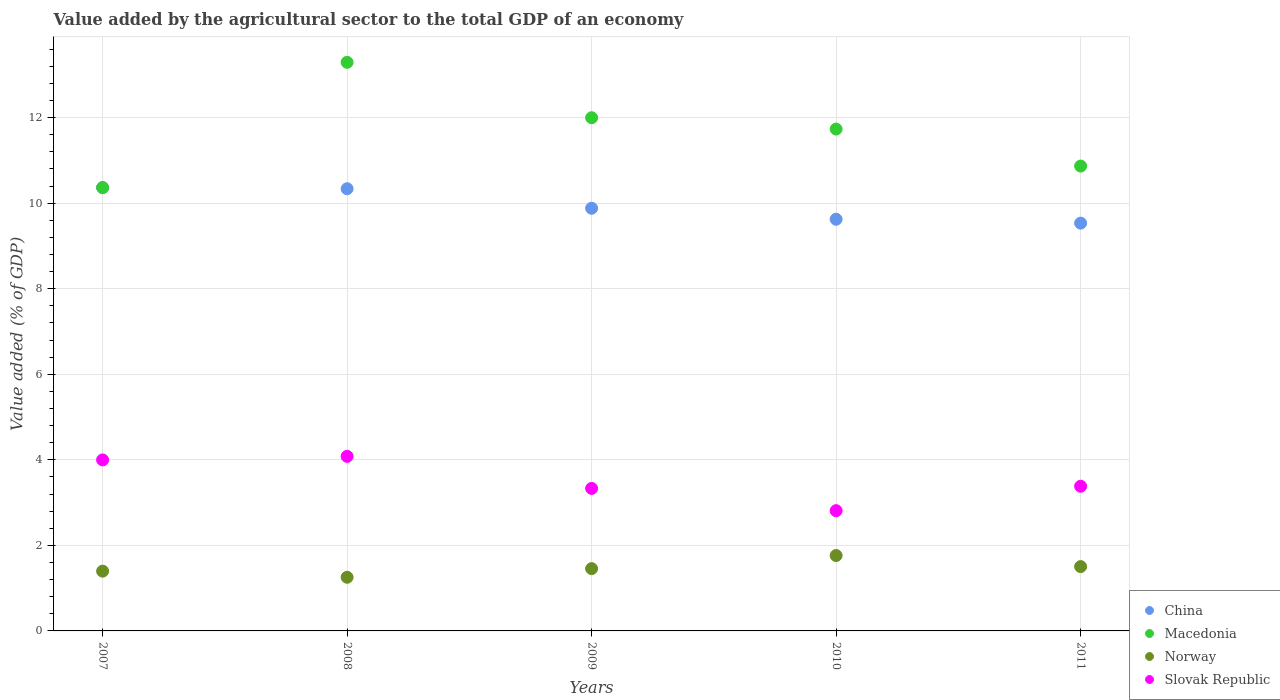How many different coloured dotlines are there?
Your answer should be compact. 4. Is the number of dotlines equal to the number of legend labels?
Provide a succinct answer. Yes. What is the value added by the agricultural sector to the total GDP in Macedonia in 2008?
Provide a short and direct response. 13.29. Across all years, what is the maximum value added by the agricultural sector to the total GDP in Slovak Republic?
Offer a terse response. 4.08. Across all years, what is the minimum value added by the agricultural sector to the total GDP in Slovak Republic?
Provide a short and direct response. 2.81. In which year was the value added by the agricultural sector to the total GDP in Norway maximum?
Provide a succinct answer. 2010. In which year was the value added by the agricultural sector to the total GDP in Slovak Republic minimum?
Your response must be concise. 2010. What is the total value added by the agricultural sector to the total GDP in Slovak Republic in the graph?
Ensure brevity in your answer.  17.61. What is the difference between the value added by the agricultural sector to the total GDP in Macedonia in 2009 and that in 2011?
Provide a succinct answer. 1.13. What is the difference between the value added by the agricultural sector to the total GDP in Macedonia in 2011 and the value added by the agricultural sector to the total GDP in Slovak Republic in 2010?
Keep it short and to the point. 8.06. What is the average value added by the agricultural sector to the total GDP in Slovak Republic per year?
Provide a succinct answer. 3.52. In the year 2009, what is the difference between the value added by the agricultural sector to the total GDP in China and value added by the agricultural sector to the total GDP in Norway?
Your answer should be compact. 8.43. In how many years, is the value added by the agricultural sector to the total GDP in Norway greater than 1.2000000000000002 %?
Make the answer very short. 5. What is the ratio of the value added by the agricultural sector to the total GDP in Norway in 2007 to that in 2011?
Your answer should be compact. 0.93. Is the difference between the value added by the agricultural sector to the total GDP in China in 2009 and 2011 greater than the difference between the value added by the agricultural sector to the total GDP in Norway in 2009 and 2011?
Offer a very short reply. Yes. What is the difference between the highest and the second highest value added by the agricultural sector to the total GDP in Macedonia?
Provide a short and direct response. 1.3. What is the difference between the highest and the lowest value added by the agricultural sector to the total GDP in China?
Offer a very short reply. 0.83. In how many years, is the value added by the agricultural sector to the total GDP in China greater than the average value added by the agricultural sector to the total GDP in China taken over all years?
Make the answer very short. 2. Does the value added by the agricultural sector to the total GDP in Slovak Republic monotonically increase over the years?
Offer a terse response. No. Is the value added by the agricultural sector to the total GDP in China strictly less than the value added by the agricultural sector to the total GDP in Macedonia over the years?
Your answer should be compact. No. Are the values on the major ticks of Y-axis written in scientific E-notation?
Your answer should be very brief. No. Does the graph contain any zero values?
Keep it short and to the point. No. Does the graph contain grids?
Your answer should be compact. Yes. Where does the legend appear in the graph?
Your answer should be very brief. Bottom right. What is the title of the graph?
Ensure brevity in your answer.  Value added by the agricultural sector to the total GDP of an economy. Does "Northern Mariana Islands" appear as one of the legend labels in the graph?
Make the answer very short. No. What is the label or title of the X-axis?
Your answer should be compact. Years. What is the label or title of the Y-axis?
Offer a very short reply. Value added (% of GDP). What is the Value added (% of GDP) in China in 2007?
Your answer should be very brief. 10.37. What is the Value added (% of GDP) of Macedonia in 2007?
Provide a short and direct response. 10.36. What is the Value added (% of GDP) of Norway in 2007?
Give a very brief answer. 1.4. What is the Value added (% of GDP) in Slovak Republic in 2007?
Offer a terse response. 4. What is the Value added (% of GDP) in China in 2008?
Give a very brief answer. 10.34. What is the Value added (% of GDP) in Macedonia in 2008?
Your response must be concise. 13.29. What is the Value added (% of GDP) in Norway in 2008?
Keep it short and to the point. 1.25. What is the Value added (% of GDP) of Slovak Republic in 2008?
Ensure brevity in your answer.  4.08. What is the Value added (% of GDP) in China in 2009?
Offer a very short reply. 9.88. What is the Value added (% of GDP) in Macedonia in 2009?
Your answer should be compact. 12. What is the Value added (% of GDP) in Norway in 2009?
Provide a succinct answer. 1.46. What is the Value added (% of GDP) of Slovak Republic in 2009?
Offer a very short reply. 3.33. What is the Value added (% of GDP) in China in 2010?
Provide a short and direct response. 9.62. What is the Value added (% of GDP) of Macedonia in 2010?
Your answer should be compact. 11.73. What is the Value added (% of GDP) of Norway in 2010?
Your answer should be very brief. 1.76. What is the Value added (% of GDP) in Slovak Republic in 2010?
Keep it short and to the point. 2.81. What is the Value added (% of GDP) in China in 2011?
Keep it short and to the point. 9.53. What is the Value added (% of GDP) in Macedonia in 2011?
Give a very brief answer. 10.87. What is the Value added (% of GDP) of Norway in 2011?
Provide a succinct answer. 1.5. What is the Value added (% of GDP) of Slovak Republic in 2011?
Give a very brief answer. 3.38. Across all years, what is the maximum Value added (% of GDP) in China?
Offer a very short reply. 10.37. Across all years, what is the maximum Value added (% of GDP) in Macedonia?
Offer a very short reply. 13.29. Across all years, what is the maximum Value added (% of GDP) in Norway?
Offer a terse response. 1.76. Across all years, what is the maximum Value added (% of GDP) of Slovak Republic?
Make the answer very short. 4.08. Across all years, what is the minimum Value added (% of GDP) in China?
Your answer should be very brief. 9.53. Across all years, what is the minimum Value added (% of GDP) in Macedonia?
Your answer should be very brief. 10.36. Across all years, what is the minimum Value added (% of GDP) of Norway?
Ensure brevity in your answer.  1.25. Across all years, what is the minimum Value added (% of GDP) of Slovak Republic?
Your response must be concise. 2.81. What is the total Value added (% of GDP) of China in the graph?
Your answer should be compact. 49.74. What is the total Value added (% of GDP) of Macedonia in the graph?
Offer a terse response. 58.26. What is the total Value added (% of GDP) of Norway in the graph?
Your answer should be very brief. 7.37. What is the total Value added (% of GDP) in Slovak Republic in the graph?
Your answer should be compact. 17.61. What is the difference between the Value added (% of GDP) of China in 2007 and that in 2008?
Give a very brief answer. 0.03. What is the difference between the Value added (% of GDP) in Macedonia in 2007 and that in 2008?
Offer a terse response. -2.93. What is the difference between the Value added (% of GDP) of Norway in 2007 and that in 2008?
Make the answer very short. 0.14. What is the difference between the Value added (% of GDP) of Slovak Republic in 2007 and that in 2008?
Your answer should be compact. -0.08. What is the difference between the Value added (% of GDP) in China in 2007 and that in 2009?
Your response must be concise. 0.48. What is the difference between the Value added (% of GDP) of Macedonia in 2007 and that in 2009?
Keep it short and to the point. -1.63. What is the difference between the Value added (% of GDP) in Norway in 2007 and that in 2009?
Give a very brief answer. -0.06. What is the difference between the Value added (% of GDP) in China in 2007 and that in 2010?
Give a very brief answer. 0.74. What is the difference between the Value added (% of GDP) in Macedonia in 2007 and that in 2010?
Make the answer very short. -1.37. What is the difference between the Value added (% of GDP) of Norway in 2007 and that in 2010?
Keep it short and to the point. -0.36. What is the difference between the Value added (% of GDP) of Slovak Republic in 2007 and that in 2010?
Your answer should be compact. 1.19. What is the difference between the Value added (% of GDP) in China in 2007 and that in 2011?
Your answer should be very brief. 0.83. What is the difference between the Value added (% of GDP) of Macedonia in 2007 and that in 2011?
Offer a terse response. -0.5. What is the difference between the Value added (% of GDP) in Norway in 2007 and that in 2011?
Your response must be concise. -0.11. What is the difference between the Value added (% of GDP) in Slovak Republic in 2007 and that in 2011?
Offer a very short reply. 0.62. What is the difference between the Value added (% of GDP) of China in 2008 and that in 2009?
Ensure brevity in your answer.  0.46. What is the difference between the Value added (% of GDP) in Macedonia in 2008 and that in 2009?
Offer a very short reply. 1.3. What is the difference between the Value added (% of GDP) in Norway in 2008 and that in 2009?
Your response must be concise. -0.2. What is the difference between the Value added (% of GDP) of Slovak Republic in 2008 and that in 2009?
Your answer should be compact. 0.75. What is the difference between the Value added (% of GDP) in China in 2008 and that in 2010?
Make the answer very short. 0.71. What is the difference between the Value added (% of GDP) of Macedonia in 2008 and that in 2010?
Offer a terse response. 1.56. What is the difference between the Value added (% of GDP) of Norway in 2008 and that in 2010?
Your answer should be compact. -0.51. What is the difference between the Value added (% of GDP) of Slovak Republic in 2008 and that in 2010?
Give a very brief answer. 1.27. What is the difference between the Value added (% of GDP) in China in 2008 and that in 2011?
Provide a short and direct response. 0.81. What is the difference between the Value added (% of GDP) in Macedonia in 2008 and that in 2011?
Your answer should be very brief. 2.43. What is the difference between the Value added (% of GDP) of Norway in 2008 and that in 2011?
Your response must be concise. -0.25. What is the difference between the Value added (% of GDP) in Slovak Republic in 2008 and that in 2011?
Your answer should be very brief. 0.7. What is the difference between the Value added (% of GDP) in China in 2009 and that in 2010?
Keep it short and to the point. 0.26. What is the difference between the Value added (% of GDP) of Macedonia in 2009 and that in 2010?
Keep it short and to the point. 0.26. What is the difference between the Value added (% of GDP) in Norway in 2009 and that in 2010?
Keep it short and to the point. -0.31. What is the difference between the Value added (% of GDP) in Slovak Republic in 2009 and that in 2010?
Provide a succinct answer. 0.52. What is the difference between the Value added (% of GDP) in China in 2009 and that in 2011?
Make the answer very short. 0.35. What is the difference between the Value added (% of GDP) of Macedonia in 2009 and that in 2011?
Make the answer very short. 1.13. What is the difference between the Value added (% of GDP) of Norway in 2009 and that in 2011?
Provide a succinct answer. -0.05. What is the difference between the Value added (% of GDP) in Slovak Republic in 2009 and that in 2011?
Make the answer very short. -0.05. What is the difference between the Value added (% of GDP) in China in 2010 and that in 2011?
Ensure brevity in your answer.  0.09. What is the difference between the Value added (% of GDP) in Macedonia in 2010 and that in 2011?
Make the answer very short. 0.87. What is the difference between the Value added (% of GDP) of Norway in 2010 and that in 2011?
Your answer should be compact. 0.26. What is the difference between the Value added (% of GDP) in Slovak Republic in 2010 and that in 2011?
Provide a short and direct response. -0.57. What is the difference between the Value added (% of GDP) in China in 2007 and the Value added (% of GDP) in Macedonia in 2008?
Your answer should be very brief. -2.93. What is the difference between the Value added (% of GDP) of China in 2007 and the Value added (% of GDP) of Norway in 2008?
Offer a very short reply. 9.11. What is the difference between the Value added (% of GDP) in China in 2007 and the Value added (% of GDP) in Slovak Republic in 2008?
Give a very brief answer. 6.28. What is the difference between the Value added (% of GDP) of Macedonia in 2007 and the Value added (% of GDP) of Norway in 2008?
Your answer should be compact. 9.11. What is the difference between the Value added (% of GDP) in Macedonia in 2007 and the Value added (% of GDP) in Slovak Republic in 2008?
Your answer should be very brief. 6.28. What is the difference between the Value added (% of GDP) of Norway in 2007 and the Value added (% of GDP) of Slovak Republic in 2008?
Offer a terse response. -2.68. What is the difference between the Value added (% of GDP) of China in 2007 and the Value added (% of GDP) of Macedonia in 2009?
Make the answer very short. -1.63. What is the difference between the Value added (% of GDP) in China in 2007 and the Value added (% of GDP) in Norway in 2009?
Offer a very short reply. 8.91. What is the difference between the Value added (% of GDP) in China in 2007 and the Value added (% of GDP) in Slovak Republic in 2009?
Make the answer very short. 7.03. What is the difference between the Value added (% of GDP) in Macedonia in 2007 and the Value added (% of GDP) in Norway in 2009?
Your answer should be very brief. 8.91. What is the difference between the Value added (% of GDP) in Macedonia in 2007 and the Value added (% of GDP) in Slovak Republic in 2009?
Make the answer very short. 7.03. What is the difference between the Value added (% of GDP) in Norway in 2007 and the Value added (% of GDP) in Slovak Republic in 2009?
Your response must be concise. -1.93. What is the difference between the Value added (% of GDP) of China in 2007 and the Value added (% of GDP) of Macedonia in 2010?
Provide a succinct answer. -1.37. What is the difference between the Value added (% of GDP) of China in 2007 and the Value added (% of GDP) of Norway in 2010?
Keep it short and to the point. 8.6. What is the difference between the Value added (% of GDP) of China in 2007 and the Value added (% of GDP) of Slovak Republic in 2010?
Offer a terse response. 7.55. What is the difference between the Value added (% of GDP) in Macedonia in 2007 and the Value added (% of GDP) in Norway in 2010?
Ensure brevity in your answer.  8.6. What is the difference between the Value added (% of GDP) in Macedonia in 2007 and the Value added (% of GDP) in Slovak Republic in 2010?
Your answer should be very brief. 7.55. What is the difference between the Value added (% of GDP) in Norway in 2007 and the Value added (% of GDP) in Slovak Republic in 2010?
Your response must be concise. -1.41. What is the difference between the Value added (% of GDP) in China in 2007 and the Value added (% of GDP) in Macedonia in 2011?
Your answer should be very brief. -0.5. What is the difference between the Value added (% of GDP) in China in 2007 and the Value added (% of GDP) in Norway in 2011?
Provide a succinct answer. 8.86. What is the difference between the Value added (% of GDP) of China in 2007 and the Value added (% of GDP) of Slovak Republic in 2011?
Make the answer very short. 6.98. What is the difference between the Value added (% of GDP) of Macedonia in 2007 and the Value added (% of GDP) of Norway in 2011?
Offer a very short reply. 8.86. What is the difference between the Value added (% of GDP) of Macedonia in 2007 and the Value added (% of GDP) of Slovak Republic in 2011?
Your response must be concise. 6.98. What is the difference between the Value added (% of GDP) of Norway in 2007 and the Value added (% of GDP) of Slovak Republic in 2011?
Provide a short and direct response. -1.99. What is the difference between the Value added (% of GDP) in China in 2008 and the Value added (% of GDP) in Macedonia in 2009?
Your answer should be compact. -1.66. What is the difference between the Value added (% of GDP) of China in 2008 and the Value added (% of GDP) of Norway in 2009?
Ensure brevity in your answer.  8.88. What is the difference between the Value added (% of GDP) in China in 2008 and the Value added (% of GDP) in Slovak Republic in 2009?
Offer a very short reply. 7.01. What is the difference between the Value added (% of GDP) in Macedonia in 2008 and the Value added (% of GDP) in Norway in 2009?
Provide a succinct answer. 11.84. What is the difference between the Value added (% of GDP) of Macedonia in 2008 and the Value added (% of GDP) of Slovak Republic in 2009?
Your answer should be very brief. 9.96. What is the difference between the Value added (% of GDP) in Norway in 2008 and the Value added (% of GDP) in Slovak Republic in 2009?
Provide a succinct answer. -2.08. What is the difference between the Value added (% of GDP) of China in 2008 and the Value added (% of GDP) of Macedonia in 2010?
Ensure brevity in your answer.  -1.39. What is the difference between the Value added (% of GDP) of China in 2008 and the Value added (% of GDP) of Norway in 2010?
Give a very brief answer. 8.58. What is the difference between the Value added (% of GDP) of China in 2008 and the Value added (% of GDP) of Slovak Republic in 2010?
Provide a succinct answer. 7.53. What is the difference between the Value added (% of GDP) of Macedonia in 2008 and the Value added (% of GDP) of Norway in 2010?
Offer a terse response. 11.53. What is the difference between the Value added (% of GDP) of Macedonia in 2008 and the Value added (% of GDP) of Slovak Republic in 2010?
Your response must be concise. 10.48. What is the difference between the Value added (% of GDP) of Norway in 2008 and the Value added (% of GDP) of Slovak Republic in 2010?
Offer a very short reply. -1.56. What is the difference between the Value added (% of GDP) in China in 2008 and the Value added (% of GDP) in Macedonia in 2011?
Provide a succinct answer. -0.53. What is the difference between the Value added (% of GDP) in China in 2008 and the Value added (% of GDP) in Norway in 2011?
Give a very brief answer. 8.83. What is the difference between the Value added (% of GDP) in China in 2008 and the Value added (% of GDP) in Slovak Republic in 2011?
Your answer should be very brief. 6.96. What is the difference between the Value added (% of GDP) in Macedonia in 2008 and the Value added (% of GDP) in Norway in 2011?
Keep it short and to the point. 11.79. What is the difference between the Value added (% of GDP) of Macedonia in 2008 and the Value added (% of GDP) of Slovak Republic in 2011?
Make the answer very short. 9.91. What is the difference between the Value added (% of GDP) in Norway in 2008 and the Value added (% of GDP) in Slovak Republic in 2011?
Keep it short and to the point. -2.13. What is the difference between the Value added (% of GDP) in China in 2009 and the Value added (% of GDP) in Macedonia in 2010?
Your response must be concise. -1.85. What is the difference between the Value added (% of GDP) in China in 2009 and the Value added (% of GDP) in Norway in 2010?
Offer a terse response. 8.12. What is the difference between the Value added (% of GDP) in China in 2009 and the Value added (% of GDP) in Slovak Republic in 2010?
Your answer should be very brief. 7.07. What is the difference between the Value added (% of GDP) of Macedonia in 2009 and the Value added (% of GDP) of Norway in 2010?
Your answer should be compact. 10.24. What is the difference between the Value added (% of GDP) of Macedonia in 2009 and the Value added (% of GDP) of Slovak Republic in 2010?
Your answer should be compact. 9.19. What is the difference between the Value added (% of GDP) in Norway in 2009 and the Value added (% of GDP) in Slovak Republic in 2010?
Your response must be concise. -1.36. What is the difference between the Value added (% of GDP) in China in 2009 and the Value added (% of GDP) in Macedonia in 2011?
Ensure brevity in your answer.  -0.99. What is the difference between the Value added (% of GDP) in China in 2009 and the Value added (% of GDP) in Norway in 2011?
Keep it short and to the point. 8.38. What is the difference between the Value added (% of GDP) of China in 2009 and the Value added (% of GDP) of Slovak Republic in 2011?
Ensure brevity in your answer.  6.5. What is the difference between the Value added (% of GDP) of Macedonia in 2009 and the Value added (% of GDP) of Norway in 2011?
Offer a very short reply. 10.49. What is the difference between the Value added (% of GDP) in Macedonia in 2009 and the Value added (% of GDP) in Slovak Republic in 2011?
Keep it short and to the point. 8.62. What is the difference between the Value added (% of GDP) in Norway in 2009 and the Value added (% of GDP) in Slovak Republic in 2011?
Your response must be concise. -1.93. What is the difference between the Value added (% of GDP) in China in 2010 and the Value added (% of GDP) in Macedonia in 2011?
Provide a succinct answer. -1.24. What is the difference between the Value added (% of GDP) in China in 2010 and the Value added (% of GDP) in Norway in 2011?
Provide a succinct answer. 8.12. What is the difference between the Value added (% of GDP) of China in 2010 and the Value added (% of GDP) of Slovak Republic in 2011?
Provide a succinct answer. 6.24. What is the difference between the Value added (% of GDP) of Macedonia in 2010 and the Value added (% of GDP) of Norway in 2011?
Your answer should be very brief. 10.23. What is the difference between the Value added (% of GDP) in Macedonia in 2010 and the Value added (% of GDP) in Slovak Republic in 2011?
Ensure brevity in your answer.  8.35. What is the difference between the Value added (% of GDP) in Norway in 2010 and the Value added (% of GDP) in Slovak Republic in 2011?
Offer a terse response. -1.62. What is the average Value added (% of GDP) in China per year?
Provide a succinct answer. 9.95. What is the average Value added (% of GDP) in Macedonia per year?
Make the answer very short. 11.65. What is the average Value added (% of GDP) in Norway per year?
Make the answer very short. 1.47. What is the average Value added (% of GDP) of Slovak Republic per year?
Make the answer very short. 3.52. In the year 2007, what is the difference between the Value added (% of GDP) of China and Value added (% of GDP) of Macedonia?
Your answer should be very brief. 0. In the year 2007, what is the difference between the Value added (% of GDP) of China and Value added (% of GDP) of Norway?
Give a very brief answer. 8.97. In the year 2007, what is the difference between the Value added (% of GDP) in China and Value added (% of GDP) in Slovak Republic?
Your response must be concise. 6.37. In the year 2007, what is the difference between the Value added (% of GDP) in Macedonia and Value added (% of GDP) in Norway?
Provide a short and direct response. 8.97. In the year 2007, what is the difference between the Value added (% of GDP) in Macedonia and Value added (% of GDP) in Slovak Republic?
Give a very brief answer. 6.37. In the year 2007, what is the difference between the Value added (% of GDP) in Norway and Value added (% of GDP) in Slovak Republic?
Your response must be concise. -2.6. In the year 2008, what is the difference between the Value added (% of GDP) in China and Value added (% of GDP) in Macedonia?
Your response must be concise. -2.96. In the year 2008, what is the difference between the Value added (% of GDP) of China and Value added (% of GDP) of Norway?
Offer a terse response. 9.08. In the year 2008, what is the difference between the Value added (% of GDP) in China and Value added (% of GDP) in Slovak Republic?
Your answer should be compact. 6.26. In the year 2008, what is the difference between the Value added (% of GDP) in Macedonia and Value added (% of GDP) in Norway?
Your response must be concise. 12.04. In the year 2008, what is the difference between the Value added (% of GDP) of Macedonia and Value added (% of GDP) of Slovak Republic?
Keep it short and to the point. 9.21. In the year 2008, what is the difference between the Value added (% of GDP) of Norway and Value added (% of GDP) of Slovak Republic?
Provide a short and direct response. -2.83. In the year 2009, what is the difference between the Value added (% of GDP) in China and Value added (% of GDP) in Macedonia?
Provide a short and direct response. -2.12. In the year 2009, what is the difference between the Value added (% of GDP) of China and Value added (% of GDP) of Norway?
Your answer should be compact. 8.43. In the year 2009, what is the difference between the Value added (% of GDP) in China and Value added (% of GDP) in Slovak Republic?
Your response must be concise. 6.55. In the year 2009, what is the difference between the Value added (% of GDP) in Macedonia and Value added (% of GDP) in Norway?
Give a very brief answer. 10.54. In the year 2009, what is the difference between the Value added (% of GDP) of Macedonia and Value added (% of GDP) of Slovak Republic?
Provide a succinct answer. 8.67. In the year 2009, what is the difference between the Value added (% of GDP) in Norway and Value added (% of GDP) in Slovak Republic?
Your response must be concise. -1.88. In the year 2010, what is the difference between the Value added (% of GDP) of China and Value added (% of GDP) of Macedonia?
Provide a short and direct response. -2.11. In the year 2010, what is the difference between the Value added (% of GDP) of China and Value added (% of GDP) of Norway?
Ensure brevity in your answer.  7.86. In the year 2010, what is the difference between the Value added (% of GDP) of China and Value added (% of GDP) of Slovak Republic?
Keep it short and to the point. 6.81. In the year 2010, what is the difference between the Value added (% of GDP) in Macedonia and Value added (% of GDP) in Norway?
Your answer should be compact. 9.97. In the year 2010, what is the difference between the Value added (% of GDP) of Macedonia and Value added (% of GDP) of Slovak Republic?
Your answer should be very brief. 8.92. In the year 2010, what is the difference between the Value added (% of GDP) in Norway and Value added (% of GDP) in Slovak Republic?
Your answer should be very brief. -1.05. In the year 2011, what is the difference between the Value added (% of GDP) in China and Value added (% of GDP) in Macedonia?
Your answer should be very brief. -1.33. In the year 2011, what is the difference between the Value added (% of GDP) in China and Value added (% of GDP) in Norway?
Offer a terse response. 8.03. In the year 2011, what is the difference between the Value added (% of GDP) of China and Value added (% of GDP) of Slovak Republic?
Offer a terse response. 6.15. In the year 2011, what is the difference between the Value added (% of GDP) in Macedonia and Value added (% of GDP) in Norway?
Give a very brief answer. 9.36. In the year 2011, what is the difference between the Value added (% of GDP) of Macedonia and Value added (% of GDP) of Slovak Republic?
Give a very brief answer. 7.49. In the year 2011, what is the difference between the Value added (% of GDP) of Norway and Value added (% of GDP) of Slovak Republic?
Ensure brevity in your answer.  -1.88. What is the ratio of the Value added (% of GDP) of China in 2007 to that in 2008?
Give a very brief answer. 1. What is the ratio of the Value added (% of GDP) in Macedonia in 2007 to that in 2008?
Offer a terse response. 0.78. What is the ratio of the Value added (% of GDP) of Norway in 2007 to that in 2008?
Your answer should be compact. 1.11. What is the ratio of the Value added (% of GDP) of Slovak Republic in 2007 to that in 2008?
Your answer should be compact. 0.98. What is the ratio of the Value added (% of GDP) in China in 2007 to that in 2009?
Offer a terse response. 1.05. What is the ratio of the Value added (% of GDP) of Macedonia in 2007 to that in 2009?
Offer a terse response. 0.86. What is the ratio of the Value added (% of GDP) in Norway in 2007 to that in 2009?
Offer a very short reply. 0.96. What is the ratio of the Value added (% of GDP) of Slovak Republic in 2007 to that in 2009?
Provide a short and direct response. 1.2. What is the ratio of the Value added (% of GDP) of China in 2007 to that in 2010?
Give a very brief answer. 1.08. What is the ratio of the Value added (% of GDP) of Macedonia in 2007 to that in 2010?
Provide a succinct answer. 0.88. What is the ratio of the Value added (% of GDP) of Norway in 2007 to that in 2010?
Provide a succinct answer. 0.79. What is the ratio of the Value added (% of GDP) in Slovak Republic in 2007 to that in 2010?
Your answer should be very brief. 1.42. What is the ratio of the Value added (% of GDP) of China in 2007 to that in 2011?
Provide a succinct answer. 1.09. What is the ratio of the Value added (% of GDP) of Macedonia in 2007 to that in 2011?
Ensure brevity in your answer.  0.95. What is the ratio of the Value added (% of GDP) of Norway in 2007 to that in 2011?
Give a very brief answer. 0.93. What is the ratio of the Value added (% of GDP) of Slovak Republic in 2007 to that in 2011?
Your response must be concise. 1.18. What is the ratio of the Value added (% of GDP) in China in 2008 to that in 2009?
Ensure brevity in your answer.  1.05. What is the ratio of the Value added (% of GDP) of Macedonia in 2008 to that in 2009?
Your response must be concise. 1.11. What is the ratio of the Value added (% of GDP) of Norway in 2008 to that in 2009?
Provide a short and direct response. 0.86. What is the ratio of the Value added (% of GDP) of Slovak Republic in 2008 to that in 2009?
Offer a very short reply. 1.23. What is the ratio of the Value added (% of GDP) of China in 2008 to that in 2010?
Keep it short and to the point. 1.07. What is the ratio of the Value added (% of GDP) of Macedonia in 2008 to that in 2010?
Keep it short and to the point. 1.13. What is the ratio of the Value added (% of GDP) of Norway in 2008 to that in 2010?
Make the answer very short. 0.71. What is the ratio of the Value added (% of GDP) in Slovak Republic in 2008 to that in 2010?
Provide a short and direct response. 1.45. What is the ratio of the Value added (% of GDP) in China in 2008 to that in 2011?
Offer a terse response. 1.08. What is the ratio of the Value added (% of GDP) of Macedonia in 2008 to that in 2011?
Keep it short and to the point. 1.22. What is the ratio of the Value added (% of GDP) of Norway in 2008 to that in 2011?
Keep it short and to the point. 0.83. What is the ratio of the Value added (% of GDP) in Slovak Republic in 2008 to that in 2011?
Provide a succinct answer. 1.21. What is the ratio of the Value added (% of GDP) of China in 2009 to that in 2010?
Offer a terse response. 1.03. What is the ratio of the Value added (% of GDP) in Macedonia in 2009 to that in 2010?
Provide a succinct answer. 1.02. What is the ratio of the Value added (% of GDP) in Norway in 2009 to that in 2010?
Make the answer very short. 0.83. What is the ratio of the Value added (% of GDP) of Slovak Republic in 2009 to that in 2010?
Give a very brief answer. 1.18. What is the ratio of the Value added (% of GDP) in China in 2009 to that in 2011?
Your response must be concise. 1.04. What is the ratio of the Value added (% of GDP) of Macedonia in 2009 to that in 2011?
Keep it short and to the point. 1.1. What is the ratio of the Value added (% of GDP) in Norway in 2009 to that in 2011?
Provide a succinct answer. 0.97. What is the ratio of the Value added (% of GDP) in Slovak Republic in 2009 to that in 2011?
Your answer should be compact. 0.98. What is the ratio of the Value added (% of GDP) of China in 2010 to that in 2011?
Provide a succinct answer. 1.01. What is the ratio of the Value added (% of GDP) of Macedonia in 2010 to that in 2011?
Your response must be concise. 1.08. What is the ratio of the Value added (% of GDP) in Norway in 2010 to that in 2011?
Ensure brevity in your answer.  1.17. What is the ratio of the Value added (% of GDP) in Slovak Republic in 2010 to that in 2011?
Offer a very short reply. 0.83. What is the difference between the highest and the second highest Value added (% of GDP) in China?
Provide a short and direct response. 0.03. What is the difference between the highest and the second highest Value added (% of GDP) in Macedonia?
Keep it short and to the point. 1.3. What is the difference between the highest and the second highest Value added (% of GDP) of Norway?
Make the answer very short. 0.26. What is the difference between the highest and the second highest Value added (% of GDP) in Slovak Republic?
Your answer should be compact. 0.08. What is the difference between the highest and the lowest Value added (% of GDP) in China?
Make the answer very short. 0.83. What is the difference between the highest and the lowest Value added (% of GDP) in Macedonia?
Provide a succinct answer. 2.93. What is the difference between the highest and the lowest Value added (% of GDP) in Norway?
Your answer should be very brief. 0.51. What is the difference between the highest and the lowest Value added (% of GDP) in Slovak Republic?
Give a very brief answer. 1.27. 